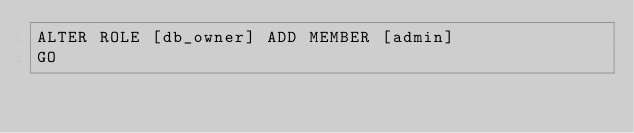Convert code to text. <code><loc_0><loc_0><loc_500><loc_500><_SQL_>ALTER ROLE [db_owner] ADD MEMBER [admin]
GO
</code> 